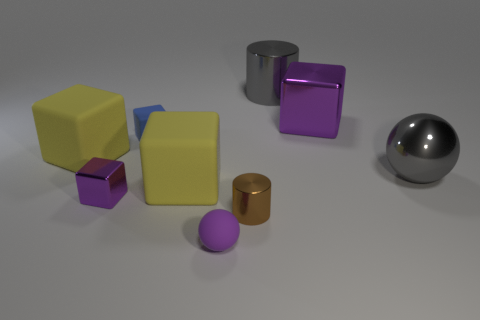What is the material of the objects and how does the light interact with them? All objects in the image seem to have a reflective, metallic surface. The light source creates highlights and reflections, giving the objects a glossy appearance. The sphere, in particular, shows a clear reflection of the environment and has a high specular highlight, indicative of a very smooth and reflective metal finish.  Are the objects arranged in any particular pattern? The objects are not arranged in a specific pattern but are rather placed randomly across the surface. There's a mix of overlap and separation between the objects that creates a casual, unstructured layout without any discernible pattern or symmetry. 